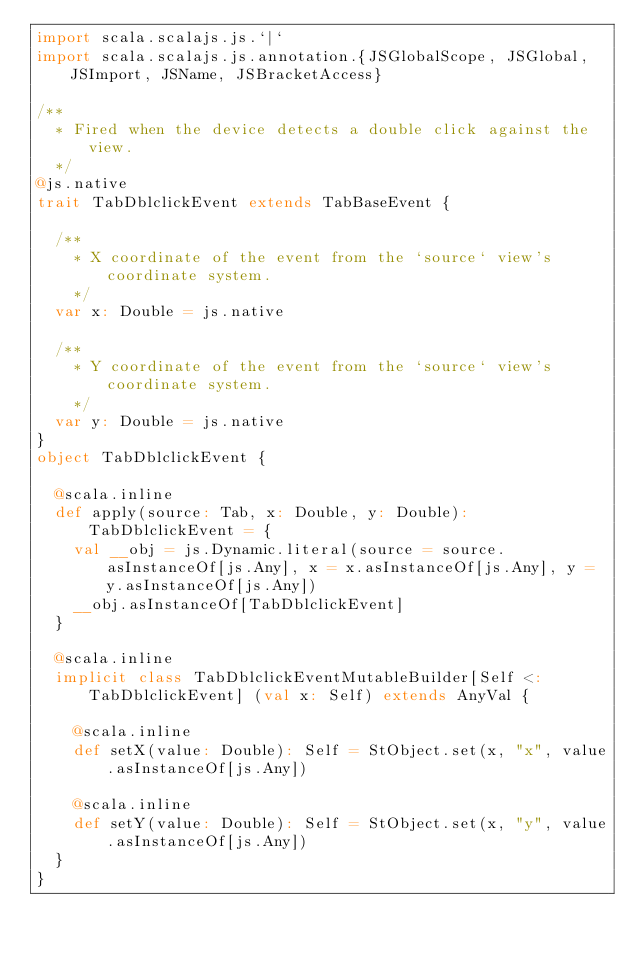<code> <loc_0><loc_0><loc_500><loc_500><_Scala_>import scala.scalajs.js.`|`
import scala.scalajs.js.annotation.{JSGlobalScope, JSGlobal, JSImport, JSName, JSBracketAccess}

/**
  * Fired when the device detects a double click against the view.
  */
@js.native
trait TabDblclickEvent extends TabBaseEvent {
  
  /**
    * X coordinate of the event from the `source` view's coordinate system.
    */
  var x: Double = js.native
  
  /**
    * Y coordinate of the event from the `source` view's coordinate system.
    */
  var y: Double = js.native
}
object TabDblclickEvent {
  
  @scala.inline
  def apply(source: Tab, x: Double, y: Double): TabDblclickEvent = {
    val __obj = js.Dynamic.literal(source = source.asInstanceOf[js.Any], x = x.asInstanceOf[js.Any], y = y.asInstanceOf[js.Any])
    __obj.asInstanceOf[TabDblclickEvent]
  }
  
  @scala.inline
  implicit class TabDblclickEventMutableBuilder[Self <: TabDblclickEvent] (val x: Self) extends AnyVal {
    
    @scala.inline
    def setX(value: Double): Self = StObject.set(x, "x", value.asInstanceOf[js.Any])
    
    @scala.inline
    def setY(value: Double): Self = StObject.set(x, "y", value.asInstanceOf[js.Any])
  }
}
</code> 